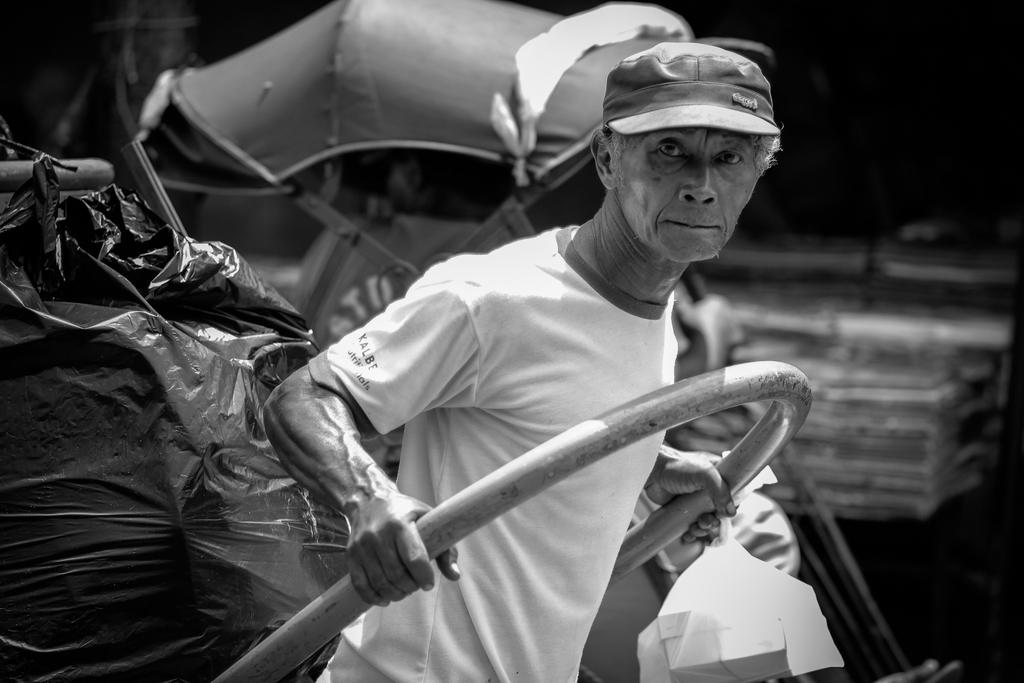What is the color scheme of the image? The image is black and white. Can you describe the main subject in the image? There is a man in the image. What is the man doing in the image? The man is pulling a cart. How many clocks can be seen hanging on the wall in the image? There are no clocks visible in the image, as it is a black and white image of a man pulling a cart. 